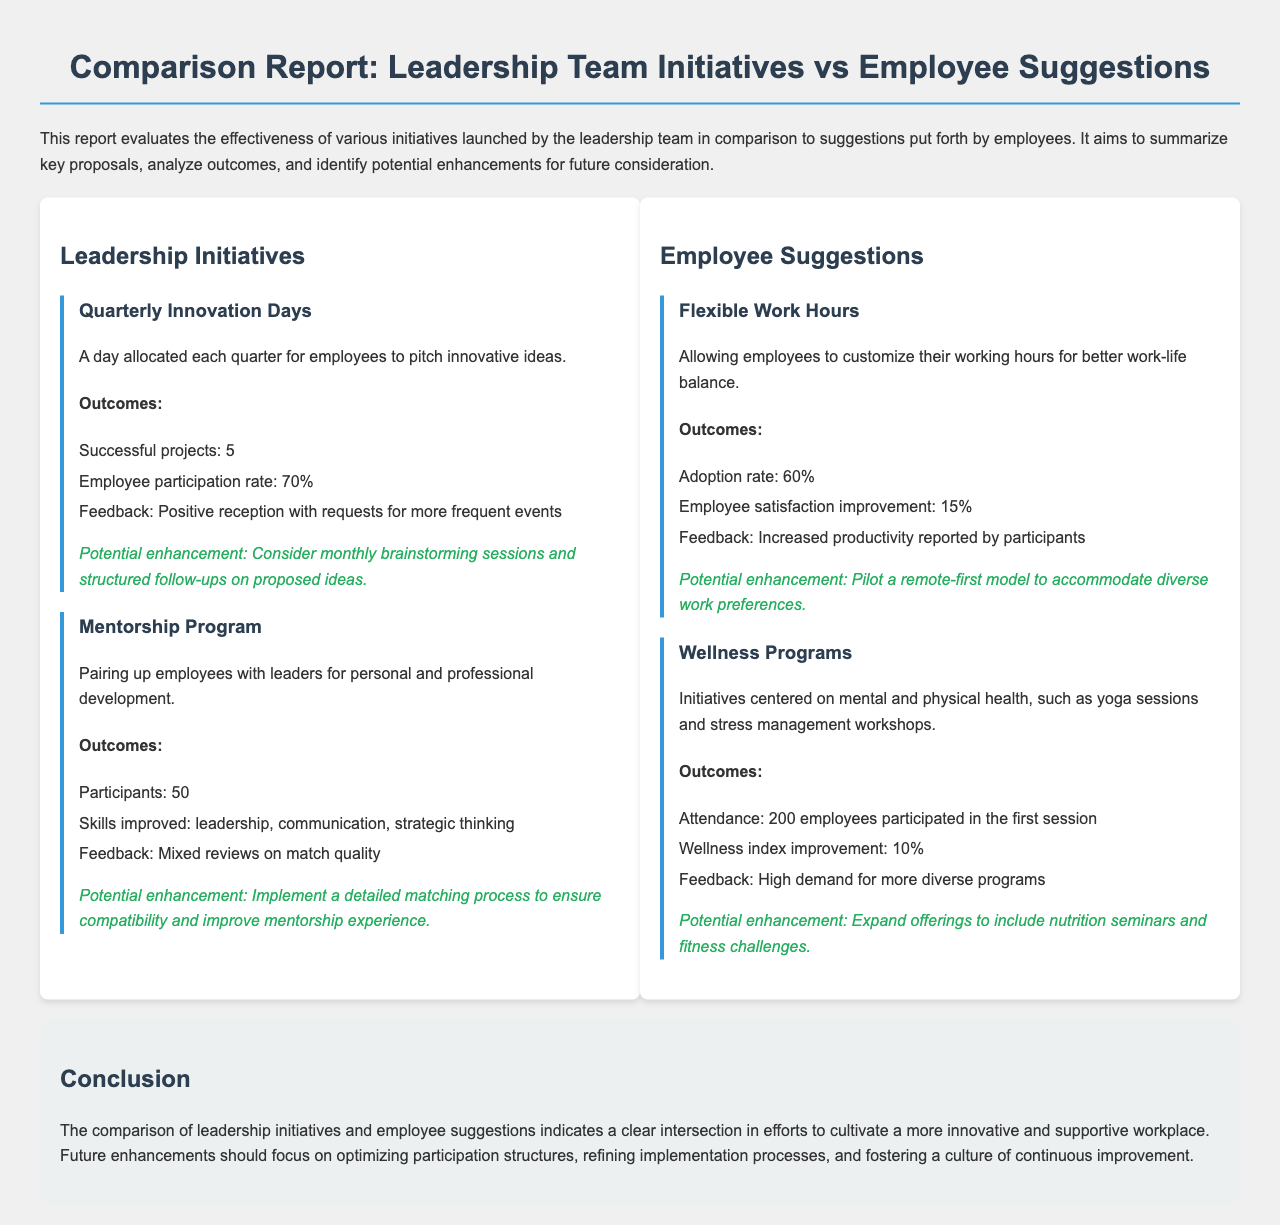What is the employee participation rate for the Quarterly Innovation Days? The employee participation rate is directly stated in the outcomes section as 70%.
Answer: 70% How many successful projects resulted from the Quarterly Innovation Days? The number of successful projects is specified in the outcomes, which indicates that there were 5 successful projects.
Answer: 5 What was the attendance for the first Wellness Programs session? The attendance figure is given in the outcomes, stating that 200 employees participated in the first session.
Answer: 200 What was the improvement in employee satisfaction associated with Flexible Work Hours? The document indicates that the employee satisfaction improvement was 15%.
Answer: 15% What is a suggested enhancement for the Mentorship Program? The report mentions the potential enhancement of implementing a detailed matching process to ensure compatibility.
Answer: Detailed matching process What is the primary feedback for the Quarterly Innovation Days? The feedback section for this initiative highlights a positive reception with requests for more frequent events.
Answer: Positive reception Which leadership initiative focuses on personal and professional development? The initiative that focuses on personal and professional development is the Mentorship Program.
Answer: Mentorship Program What wellness initiative could expand to include nutrition seminars? The wellness initiative referred to in the context of expanding offerings is the Wellness Programs.
Answer: Wellness Programs What is the conclusion of the report regarding future enhancements? The report concludes that future enhancements should focus on optimizing participation structures and refining implementation processes.
Answer: Optimize participation structures 